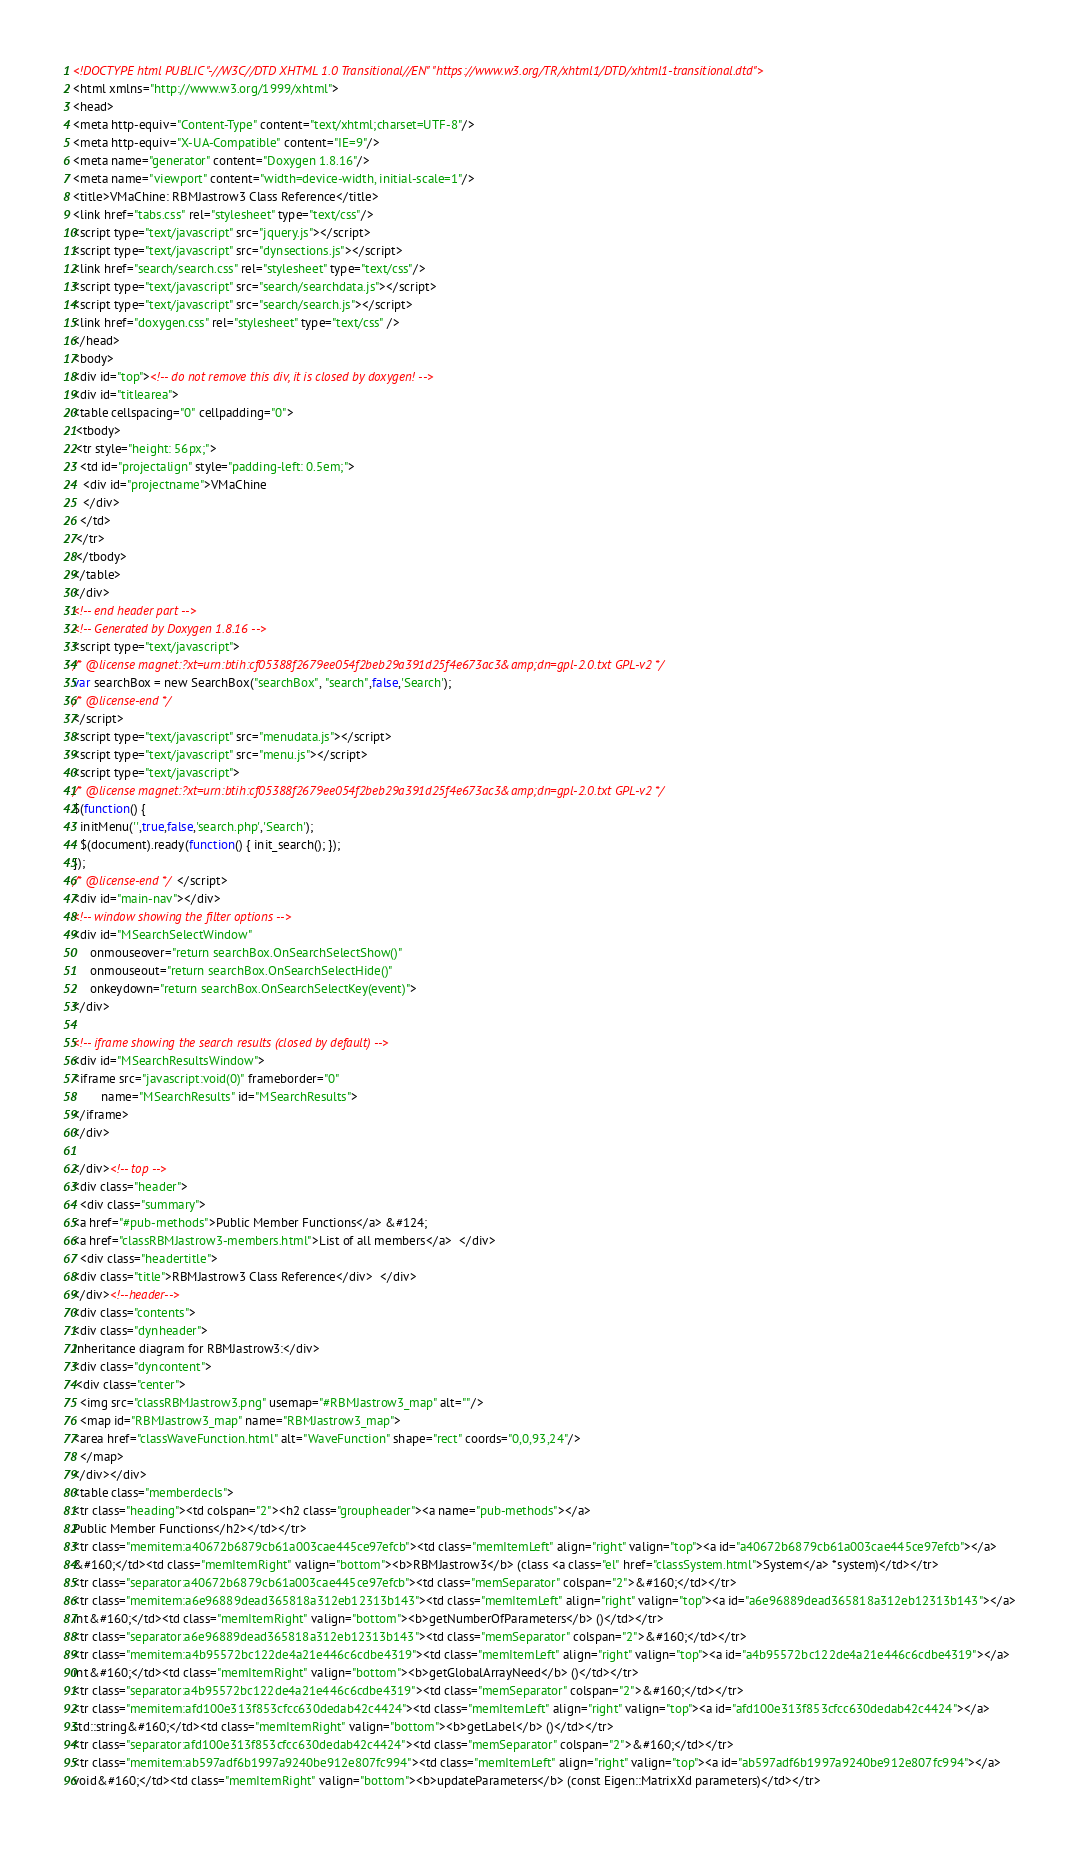<code> <loc_0><loc_0><loc_500><loc_500><_HTML_><!DOCTYPE html PUBLIC "-//W3C//DTD XHTML 1.0 Transitional//EN" "https://www.w3.org/TR/xhtml1/DTD/xhtml1-transitional.dtd">
<html xmlns="http://www.w3.org/1999/xhtml">
<head>
<meta http-equiv="Content-Type" content="text/xhtml;charset=UTF-8"/>
<meta http-equiv="X-UA-Compatible" content="IE=9"/>
<meta name="generator" content="Doxygen 1.8.16"/>
<meta name="viewport" content="width=device-width, initial-scale=1"/>
<title>VMaChine: RBMJastrow3 Class Reference</title>
<link href="tabs.css" rel="stylesheet" type="text/css"/>
<script type="text/javascript" src="jquery.js"></script>
<script type="text/javascript" src="dynsections.js"></script>
<link href="search/search.css" rel="stylesheet" type="text/css"/>
<script type="text/javascript" src="search/searchdata.js"></script>
<script type="text/javascript" src="search/search.js"></script>
<link href="doxygen.css" rel="stylesheet" type="text/css" />
</head>
<body>
<div id="top"><!-- do not remove this div, it is closed by doxygen! -->
<div id="titlearea">
<table cellspacing="0" cellpadding="0">
 <tbody>
 <tr style="height: 56px;">
  <td id="projectalign" style="padding-left: 0.5em;">
   <div id="projectname">VMaChine
   </div>
  </td>
 </tr>
 </tbody>
</table>
</div>
<!-- end header part -->
<!-- Generated by Doxygen 1.8.16 -->
<script type="text/javascript">
/* @license magnet:?xt=urn:btih:cf05388f2679ee054f2beb29a391d25f4e673ac3&amp;dn=gpl-2.0.txt GPL-v2 */
var searchBox = new SearchBox("searchBox", "search",false,'Search');
/* @license-end */
</script>
<script type="text/javascript" src="menudata.js"></script>
<script type="text/javascript" src="menu.js"></script>
<script type="text/javascript">
/* @license magnet:?xt=urn:btih:cf05388f2679ee054f2beb29a391d25f4e673ac3&amp;dn=gpl-2.0.txt GPL-v2 */
$(function() {
  initMenu('',true,false,'search.php','Search');
  $(document).ready(function() { init_search(); });
});
/* @license-end */</script>
<div id="main-nav"></div>
<!-- window showing the filter options -->
<div id="MSearchSelectWindow"
     onmouseover="return searchBox.OnSearchSelectShow()"
     onmouseout="return searchBox.OnSearchSelectHide()"
     onkeydown="return searchBox.OnSearchSelectKey(event)">
</div>

<!-- iframe showing the search results (closed by default) -->
<div id="MSearchResultsWindow">
<iframe src="javascript:void(0)" frameborder="0" 
        name="MSearchResults" id="MSearchResults">
</iframe>
</div>

</div><!-- top -->
<div class="header">
  <div class="summary">
<a href="#pub-methods">Public Member Functions</a> &#124;
<a href="classRBMJastrow3-members.html">List of all members</a>  </div>
  <div class="headertitle">
<div class="title">RBMJastrow3 Class Reference</div>  </div>
</div><!--header-->
<div class="contents">
<div class="dynheader">
Inheritance diagram for RBMJastrow3:</div>
<div class="dyncontent">
 <div class="center">
  <img src="classRBMJastrow3.png" usemap="#RBMJastrow3_map" alt=""/>
  <map id="RBMJastrow3_map" name="RBMJastrow3_map">
<area href="classWaveFunction.html" alt="WaveFunction" shape="rect" coords="0,0,93,24"/>
  </map>
</div></div>
<table class="memberdecls">
<tr class="heading"><td colspan="2"><h2 class="groupheader"><a name="pub-methods"></a>
Public Member Functions</h2></td></tr>
<tr class="memitem:a40672b6879cb61a003cae445ce97efcb"><td class="memItemLeft" align="right" valign="top"><a id="a40672b6879cb61a003cae445ce97efcb"></a>
&#160;</td><td class="memItemRight" valign="bottom"><b>RBMJastrow3</b> (class <a class="el" href="classSystem.html">System</a> *system)</td></tr>
<tr class="separator:a40672b6879cb61a003cae445ce97efcb"><td class="memSeparator" colspan="2">&#160;</td></tr>
<tr class="memitem:a6e96889dead365818a312eb12313b143"><td class="memItemLeft" align="right" valign="top"><a id="a6e96889dead365818a312eb12313b143"></a>
int&#160;</td><td class="memItemRight" valign="bottom"><b>getNumberOfParameters</b> ()</td></tr>
<tr class="separator:a6e96889dead365818a312eb12313b143"><td class="memSeparator" colspan="2">&#160;</td></tr>
<tr class="memitem:a4b95572bc122de4a21e446c6cdbe4319"><td class="memItemLeft" align="right" valign="top"><a id="a4b95572bc122de4a21e446c6cdbe4319"></a>
int&#160;</td><td class="memItemRight" valign="bottom"><b>getGlobalArrayNeed</b> ()</td></tr>
<tr class="separator:a4b95572bc122de4a21e446c6cdbe4319"><td class="memSeparator" colspan="2">&#160;</td></tr>
<tr class="memitem:afd100e313f853cfcc630dedab42c4424"><td class="memItemLeft" align="right" valign="top"><a id="afd100e313f853cfcc630dedab42c4424"></a>
std::string&#160;</td><td class="memItemRight" valign="bottom"><b>getLabel</b> ()</td></tr>
<tr class="separator:afd100e313f853cfcc630dedab42c4424"><td class="memSeparator" colspan="2">&#160;</td></tr>
<tr class="memitem:ab597adf6b1997a9240be912e807fc994"><td class="memItemLeft" align="right" valign="top"><a id="ab597adf6b1997a9240be912e807fc994"></a>
void&#160;</td><td class="memItemRight" valign="bottom"><b>updateParameters</b> (const Eigen::MatrixXd parameters)</td></tr></code> 